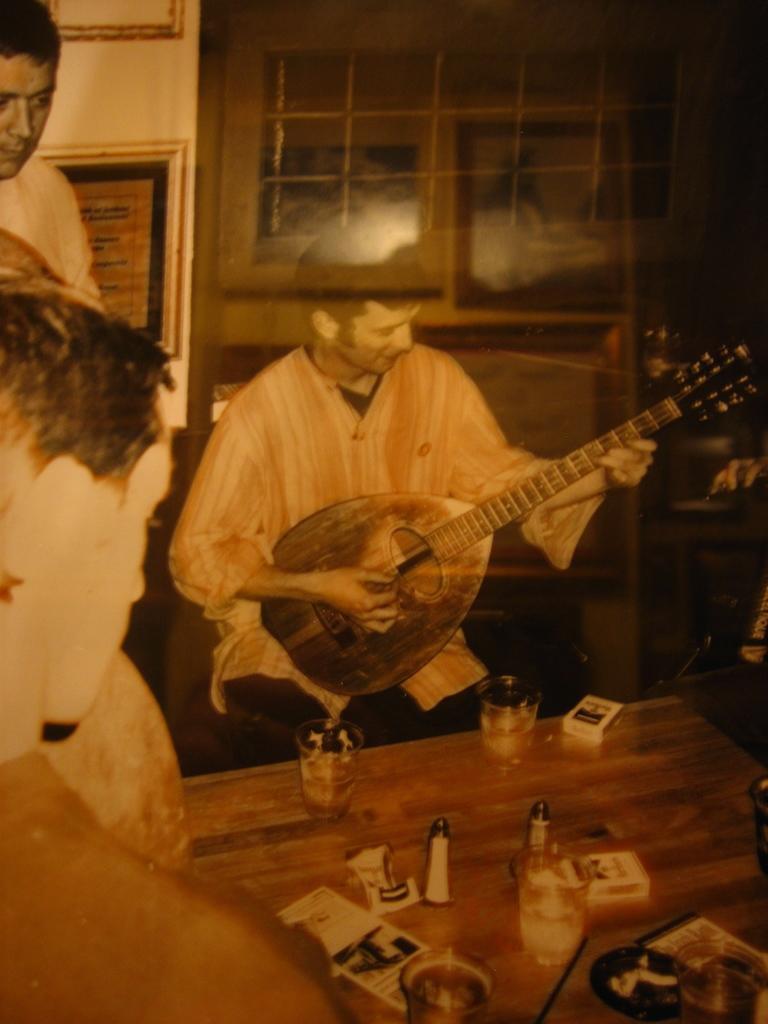How would you summarize this image in a sentence or two? In this picture we can see a person holding a guitar. There are glasses, box and other objects on the table. We can see a few people on the left side. There are a few frames on the wall. 